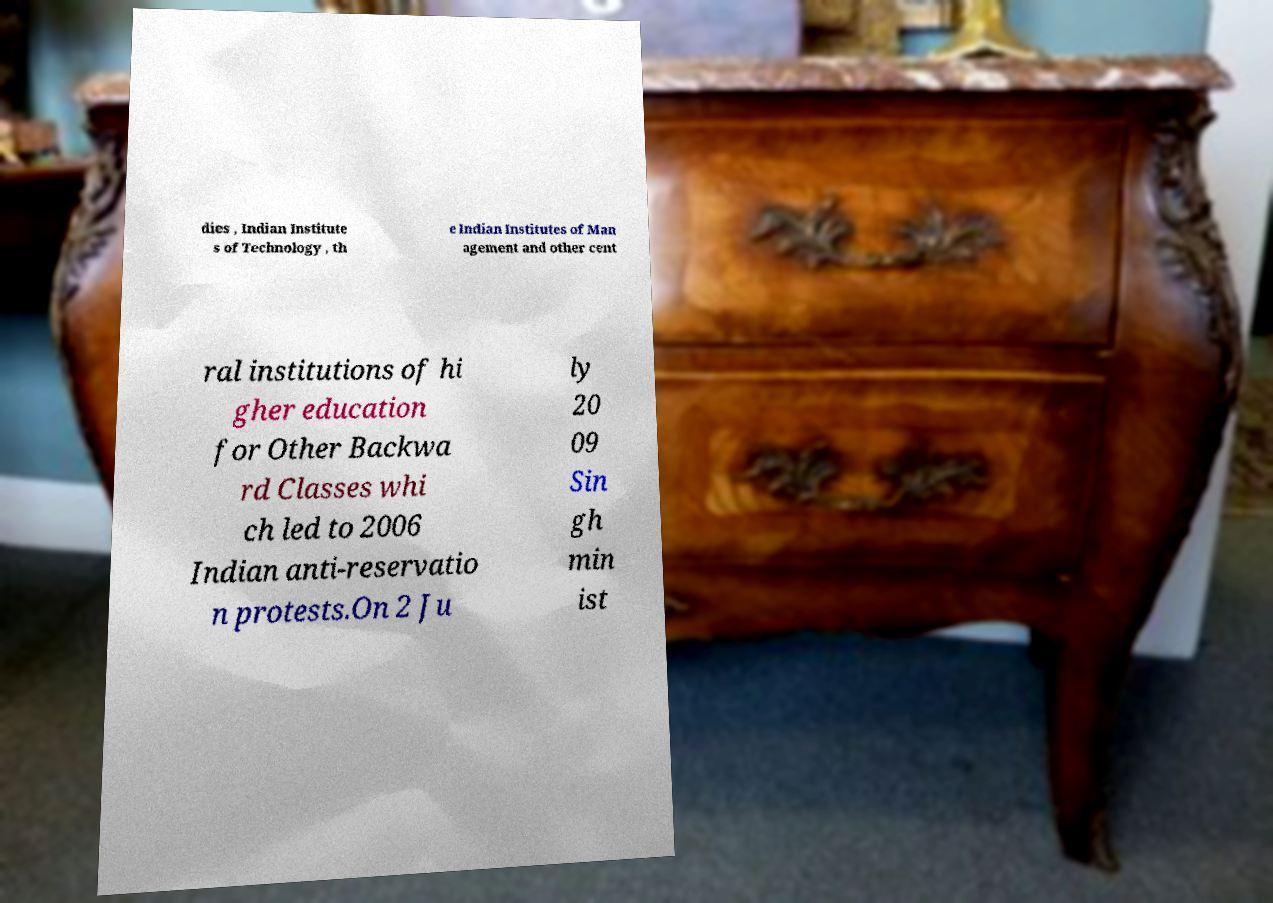Could you assist in decoding the text presented in this image and type it out clearly? dies , Indian Institute s of Technology , th e Indian Institutes of Man agement and other cent ral institutions of hi gher education for Other Backwa rd Classes whi ch led to 2006 Indian anti-reservatio n protests.On 2 Ju ly 20 09 Sin gh min ist 